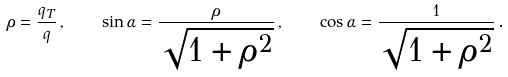<formula> <loc_0><loc_0><loc_500><loc_500>\rho = \frac { q _ { T } } { q } \, , \quad \sin \alpha = \frac { \rho } { \sqrt { 1 + \rho ^ { 2 } } } \, , \quad \cos \alpha = \frac { 1 } { \sqrt { 1 + \rho ^ { 2 } } } \, .</formula> 